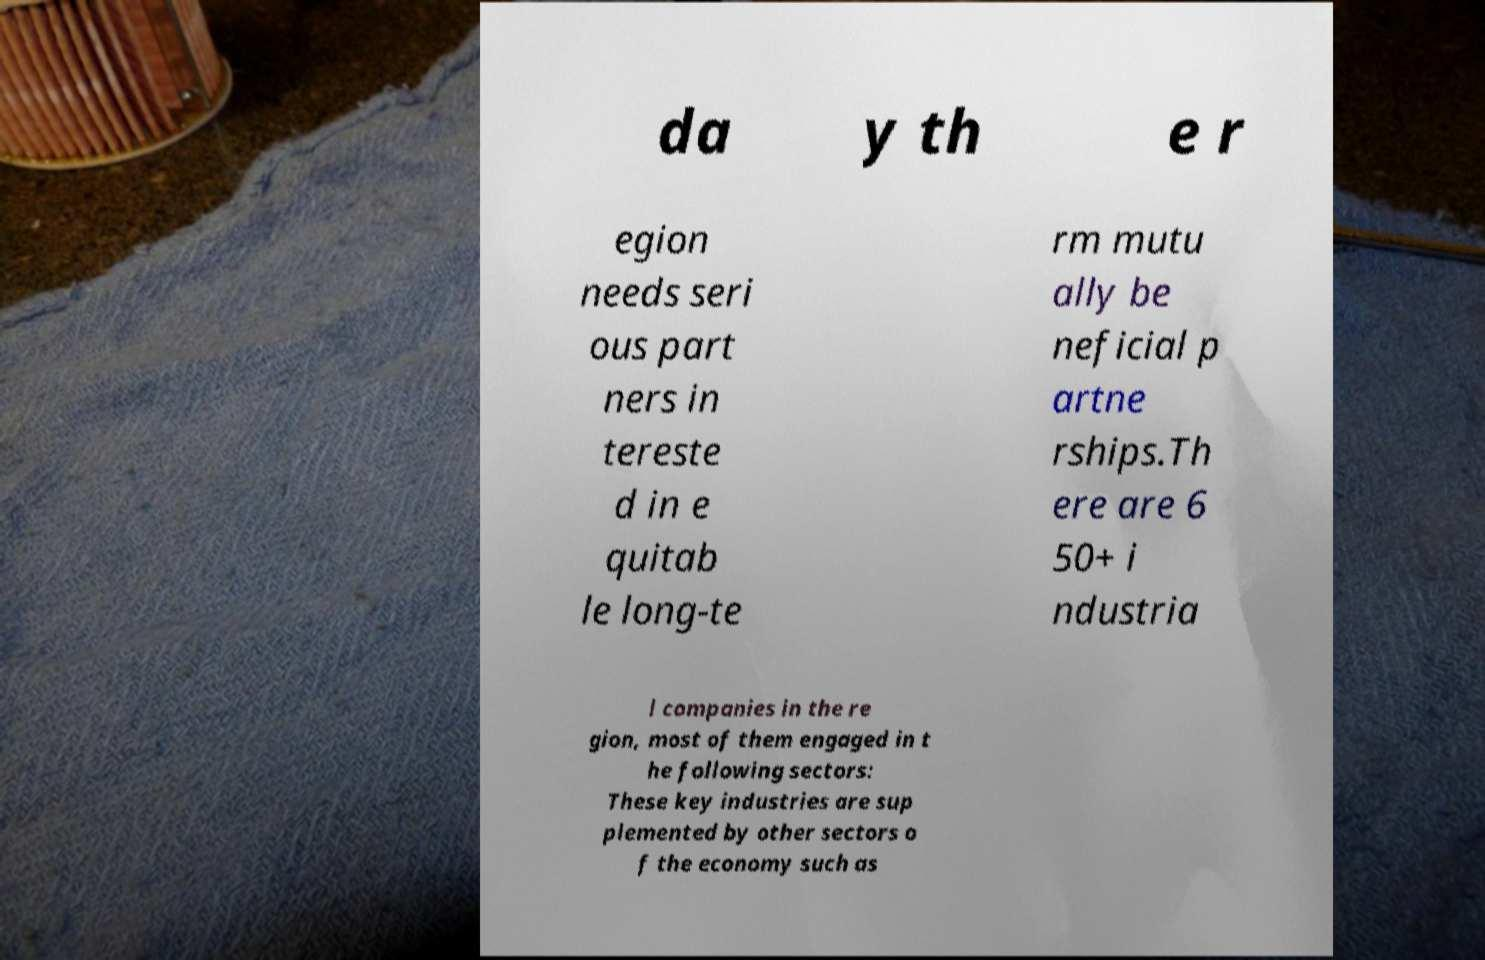For documentation purposes, I need the text within this image transcribed. Could you provide that? da y th e r egion needs seri ous part ners in tereste d in e quitab le long-te rm mutu ally be neficial p artne rships.Th ere are 6 50+ i ndustria l companies in the re gion, most of them engaged in t he following sectors: These key industries are sup plemented by other sectors o f the economy such as 